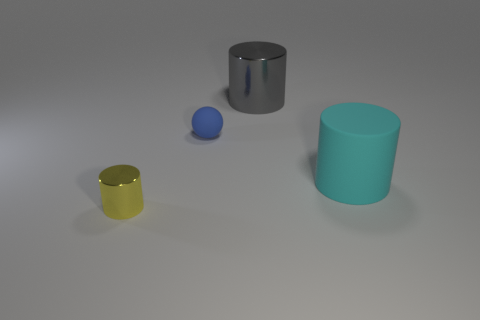How many small yellow shiny objects are there?
Give a very brief answer. 1. How many large objects are yellow objects or brown shiny cylinders?
Provide a succinct answer. 0. There is a thing that is to the right of the large cylinder that is behind the cylinder right of the big gray cylinder; what color is it?
Provide a succinct answer. Cyan. How many other things are the same color as the large metal cylinder?
Offer a terse response. 0. How many shiny objects are either brown cylinders or gray things?
Keep it short and to the point. 1. Do the small object behind the yellow cylinder and the metal thing that is in front of the small blue sphere have the same color?
Make the answer very short. No. Is there any other thing that is the same material as the small blue thing?
Keep it short and to the point. Yes. What is the size of the gray shiny object that is the same shape as the cyan object?
Ensure brevity in your answer.  Large. Are there more big cyan cylinders that are left of the small yellow metallic object than tiny purple spheres?
Ensure brevity in your answer.  No. Does the cylinder on the right side of the gray cylinder have the same material as the big gray cylinder?
Ensure brevity in your answer.  No. 